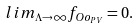Convert formula to latex. <formula><loc_0><loc_0><loc_500><loc_500>l i m _ { \Lambda \to \infty } f _ { O o _ { P V } } = 0 .</formula> 